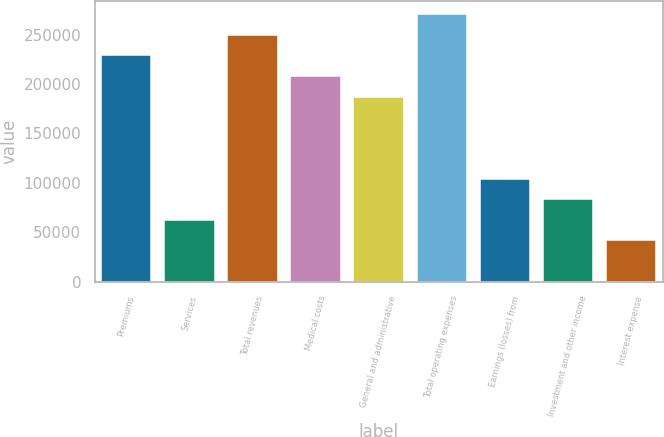Convert chart to OTSL. <chart><loc_0><loc_0><loc_500><loc_500><bar_chart><fcel>Premiums<fcel>Services<fcel>Total revenues<fcel>Medical costs<fcel>General and administrative<fcel>Total operating expenses<fcel>Earnings (losses) from<fcel>Investment and other income<fcel>Interest expense<nl><fcel>228844<fcel>62417.4<fcel>249648<fcel>208041<fcel>187238<fcel>270451<fcel>104024<fcel>83220.8<fcel>41614.1<nl></chart> 